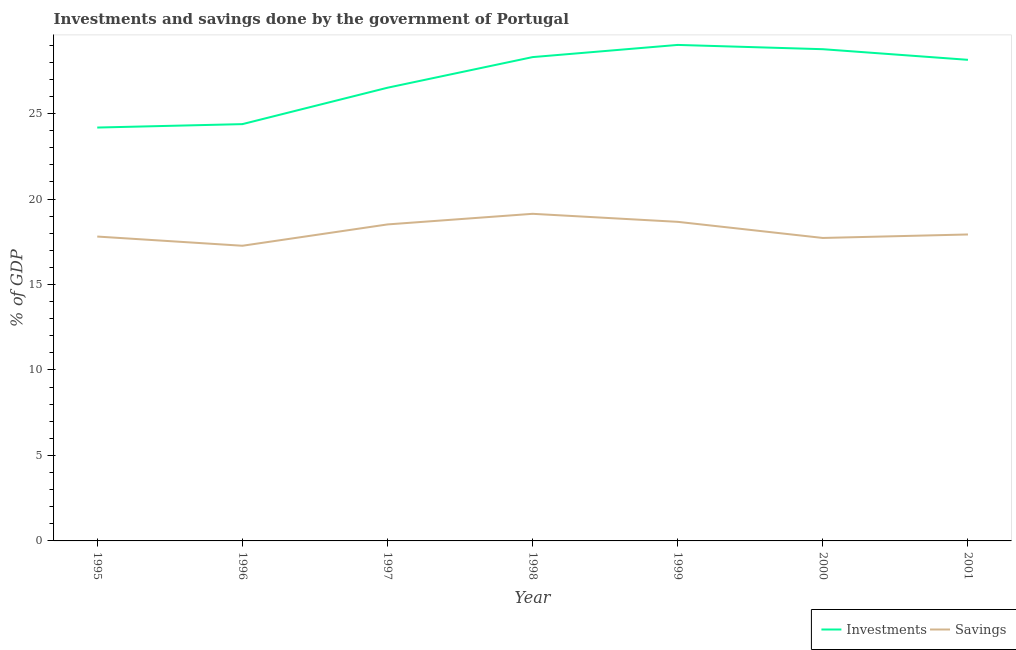Does the line corresponding to investments of government intersect with the line corresponding to savings of government?
Keep it short and to the point. No. What is the savings of government in 1998?
Ensure brevity in your answer.  19.13. Across all years, what is the maximum investments of government?
Ensure brevity in your answer.  29.01. Across all years, what is the minimum savings of government?
Keep it short and to the point. 17.27. In which year was the investments of government maximum?
Give a very brief answer. 1999. What is the total investments of government in the graph?
Your answer should be very brief. 189.3. What is the difference between the savings of government in 1997 and that in 2001?
Offer a terse response. 0.59. What is the difference between the investments of government in 1999 and the savings of government in 2000?
Keep it short and to the point. 11.29. What is the average investments of government per year?
Provide a succinct answer. 27.04. In the year 2000, what is the difference between the savings of government and investments of government?
Give a very brief answer. -11.04. What is the ratio of the savings of government in 1995 to that in 1999?
Offer a very short reply. 0.95. What is the difference between the highest and the second highest investments of government?
Offer a terse response. 0.25. What is the difference between the highest and the lowest savings of government?
Keep it short and to the point. 1.87. In how many years, is the savings of government greater than the average savings of government taken over all years?
Provide a succinct answer. 3. Is the savings of government strictly greater than the investments of government over the years?
Your response must be concise. No. How many lines are there?
Make the answer very short. 2. How many years are there in the graph?
Provide a succinct answer. 7. What is the difference between two consecutive major ticks on the Y-axis?
Your response must be concise. 5. Where does the legend appear in the graph?
Give a very brief answer. Bottom right. How many legend labels are there?
Your response must be concise. 2. What is the title of the graph?
Provide a succinct answer. Investments and savings done by the government of Portugal. What is the label or title of the Y-axis?
Make the answer very short. % of GDP. What is the % of GDP in Investments in 1995?
Offer a terse response. 24.18. What is the % of GDP in Savings in 1995?
Give a very brief answer. 17.8. What is the % of GDP of Investments in 1996?
Your answer should be compact. 24.38. What is the % of GDP in Savings in 1996?
Your answer should be very brief. 17.27. What is the % of GDP in Investments in 1997?
Your response must be concise. 26.51. What is the % of GDP in Savings in 1997?
Offer a very short reply. 18.51. What is the % of GDP of Investments in 1998?
Offer a terse response. 28.3. What is the % of GDP in Savings in 1998?
Your answer should be very brief. 19.13. What is the % of GDP of Investments in 1999?
Your response must be concise. 29.01. What is the % of GDP in Savings in 1999?
Ensure brevity in your answer.  18.67. What is the % of GDP in Investments in 2000?
Ensure brevity in your answer.  28.76. What is the % of GDP of Savings in 2000?
Offer a very short reply. 17.72. What is the % of GDP in Investments in 2001?
Offer a terse response. 28.14. What is the % of GDP of Savings in 2001?
Your response must be concise. 17.93. Across all years, what is the maximum % of GDP in Investments?
Ensure brevity in your answer.  29.01. Across all years, what is the maximum % of GDP of Savings?
Ensure brevity in your answer.  19.13. Across all years, what is the minimum % of GDP in Investments?
Make the answer very short. 24.18. Across all years, what is the minimum % of GDP of Savings?
Make the answer very short. 17.27. What is the total % of GDP in Investments in the graph?
Offer a terse response. 189.3. What is the total % of GDP in Savings in the graph?
Provide a succinct answer. 127.04. What is the difference between the % of GDP of Investments in 1995 and that in 1996?
Keep it short and to the point. -0.2. What is the difference between the % of GDP in Savings in 1995 and that in 1996?
Your answer should be compact. 0.54. What is the difference between the % of GDP of Investments in 1995 and that in 1997?
Give a very brief answer. -2.33. What is the difference between the % of GDP of Savings in 1995 and that in 1997?
Provide a short and direct response. -0.71. What is the difference between the % of GDP in Investments in 1995 and that in 1998?
Offer a terse response. -4.12. What is the difference between the % of GDP in Savings in 1995 and that in 1998?
Provide a succinct answer. -1.33. What is the difference between the % of GDP of Investments in 1995 and that in 1999?
Provide a succinct answer. -4.83. What is the difference between the % of GDP of Savings in 1995 and that in 1999?
Keep it short and to the point. -0.86. What is the difference between the % of GDP in Investments in 1995 and that in 2000?
Ensure brevity in your answer.  -4.58. What is the difference between the % of GDP of Savings in 1995 and that in 2000?
Make the answer very short. 0.08. What is the difference between the % of GDP of Investments in 1995 and that in 2001?
Provide a succinct answer. -3.96. What is the difference between the % of GDP in Savings in 1995 and that in 2001?
Give a very brief answer. -0.12. What is the difference between the % of GDP of Investments in 1996 and that in 1997?
Your response must be concise. -2.13. What is the difference between the % of GDP of Savings in 1996 and that in 1997?
Offer a very short reply. -1.25. What is the difference between the % of GDP of Investments in 1996 and that in 1998?
Ensure brevity in your answer.  -3.92. What is the difference between the % of GDP of Savings in 1996 and that in 1998?
Ensure brevity in your answer.  -1.87. What is the difference between the % of GDP of Investments in 1996 and that in 1999?
Your response must be concise. -4.63. What is the difference between the % of GDP in Savings in 1996 and that in 1999?
Your response must be concise. -1.4. What is the difference between the % of GDP of Investments in 1996 and that in 2000?
Offer a very short reply. -4.38. What is the difference between the % of GDP of Savings in 1996 and that in 2000?
Your answer should be very brief. -0.46. What is the difference between the % of GDP in Investments in 1996 and that in 2001?
Give a very brief answer. -3.76. What is the difference between the % of GDP of Savings in 1996 and that in 2001?
Your response must be concise. -0.66. What is the difference between the % of GDP of Investments in 1997 and that in 1998?
Your answer should be very brief. -1.79. What is the difference between the % of GDP of Savings in 1997 and that in 1998?
Make the answer very short. -0.62. What is the difference between the % of GDP of Investments in 1997 and that in 1999?
Your response must be concise. -2.5. What is the difference between the % of GDP in Savings in 1997 and that in 1999?
Your answer should be compact. -0.15. What is the difference between the % of GDP in Investments in 1997 and that in 2000?
Your response must be concise. -2.25. What is the difference between the % of GDP of Savings in 1997 and that in 2000?
Your answer should be compact. 0.79. What is the difference between the % of GDP in Investments in 1997 and that in 2001?
Make the answer very short. -1.63. What is the difference between the % of GDP in Savings in 1997 and that in 2001?
Offer a terse response. 0.59. What is the difference between the % of GDP of Investments in 1998 and that in 1999?
Keep it short and to the point. -0.71. What is the difference between the % of GDP in Savings in 1998 and that in 1999?
Provide a short and direct response. 0.47. What is the difference between the % of GDP in Investments in 1998 and that in 2000?
Your answer should be compact. -0.46. What is the difference between the % of GDP of Savings in 1998 and that in 2000?
Your answer should be compact. 1.41. What is the difference between the % of GDP of Investments in 1998 and that in 2001?
Give a very brief answer. 0.16. What is the difference between the % of GDP of Savings in 1998 and that in 2001?
Ensure brevity in your answer.  1.21. What is the difference between the % of GDP in Investments in 1999 and that in 2000?
Give a very brief answer. 0.25. What is the difference between the % of GDP of Savings in 1999 and that in 2000?
Ensure brevity in your answer.  0.94. What is the difference between the % of GDP in Investments in 1999 and that in 2001?
Make the answer very short. 0.87. What is the difference between the % of GDP of Savings in 1999 and that in 2001?
Your answer should be very brief. 0.74. What is the difference between the % of GDP of Investments in 2000 and that in 2001?
Your answer should be compact. 0.62. What is the difference between the % of GDP in Savings in 2000 and that in 2001?
Offer a terse response. -0.2. What is the difference between the % of GDP in Investments in 1995 and the % of GDP in Savings in 1996?
Provide a short and direct response. 6.91. What is the difference between the % of GDP in Investments in 1995 and the % of GDP in Savings in 1997?
Your answer should be very brief. 5.67. What is the difference between the % of GDP of Investments in 1995 and the % of GDP of Savings in 1998?
Keep it short and to the point. 5.05. What is the difference between the % of GDP in Investments in 1995 and the % of GDP in Savings in 1999?
Offer a very short reply. 5.52. What is the difference between the % of GDP in Investments in 1995 and the % of GDP in Savings in 2000?
Provide a short and direct response. 6.46. What is the difference between the % of GDP in Investments in 1995 and the % of GDP in Savings in 2001?
Your response must be concise. 6.25. What is the difference between the % of GDP of Investments in 1996 and the % of GDP of Savings in 1997?
Your response must be concise. 5.87. What is the difference between the % of GDP of Investments in 1996 and the % of GDP of Savings in 1998?
Offer a terse response. 5.25. What is the difference between the % of GDP of Investments in 1996 and the % of GDP of Savings in 1999?
Offer a very short reply. 5.72. What is the difference between the % of GDP of Investments in 1996 and the % of GDP of Savings in 2000?
Offer a terse response. 6.66. What is the difference between the % of GDP of Investments in 1996 and the % of GDP of Savings in 2001?
Your answer should be compact. 6.45. What is the difference between the % of GDP of Investments in 1997 and the % of GDP of Savings in 1998?
Make the answer very short. 7.38. What is the difference between the % of GDP in Investments in 1997 and the % of GDP in Savings in 1999?
Your response must be concise. 7.85. What is the difference between the % of GDP of Investments in 1997 and the % of GDP of Savings in 2000?
Provide a succinct answer. 8.79. What is the difference between the % of GDP in Investments in 1997 and the % of GDP in Savings in 2001?
Make the answer very short. 8.58. What is the difference between the % of GDP in Investments in 1998 and the % of GDP in Savings in 1999?
Keep it short and to the point. 9.64. What is the difference between the % of GDP in Investments in 1998 and the % of GDP in Savings in 2000?
Your answer should be compact. 10.58. What is the difference between the % of GDP of Investments in 1998 and the % of GDP of Savings in 2001?
Provide a short and direct response. 10.38. What is the difference between the % of GDP in Investments in 1999 and the % of GDP in Savings in 2000?
Your response must be concise. 11.29. What is the difference between the % of GDP of Investments in 1999 and the % of GDP of Savings in 2001?
Offer a terse response. 11.09. What is the difference between the % of GDP of Investments in 2000 and the % of GDP of Savings in 2001?
Keep it short and to the point. 10.84. What is the average % of GDP in Investments per year?
Offer a terse response. 27.04. What is the average % of GDP in Savings per year?
Offer a terse response. 18.15. In the year 1995, what is the difference between the % of GDP in Investments and % of GDP in Savings?
Provide a short and direct response. 6.38. In the year 1996, what is the difference between the % of GDP in Investments and % of GDP in Savings?
Keep it short and to the point. 7.11. In the year 1997, what is the difference between the % of GDP in Investments and % of GDP in Savings?
Your answer should be very brief. 8. In the year 1998, what is the difference between the % of GDP of Investments and % of GDP of Savings?
Your answer should be compact. 9.17. In the year 1999, what is the difference between the % of GDP of Investments and % of GDP of Savings?
Your response must be concise. 10.35. In the year 2000, what is the difference between the % of GDP of Investments and % of GDP of Savings?
Your answer should be compact. 11.04. In the year 2001, what is the difference between the % of GDP of Investments and % of GDP of Savings?
Your answer should be compact. 10.22. What is the ratio of the % of GDP in Savings in 1995 to that in 1996?
Give a very brief answer. 1.03. What is the ratio of the % of GDP of Investments in 1995 to that in 1997?
Provide a succinct answer. 0.91. What is the ratio of the % of GDP of Savings in 1995 to that in 1997?
Your answer should be compact. 0.96. What is the ratio of the % of GDP in Investments in 1995 to that in 1998?
Ensure brevity in your answer.  0.85. What is the ratio of the % of GDP in Savings in 1995 to that in 1998?
Offer a very short reply. 0.93. What is the ratio of the % of GDP of Investments in 1995 to that in 1999?
Offer a terse response. 0.83. What is the ratio of the % of GDP of Savings in 1995 to that in 1999?
Ensure brevity in your answer.  0.95. What is the ratio of the % of GDP of Investments in 1995 to that in 2000?
Make the answer very short. 0.84. What is the ratio of the % of GDP in Investments in 1995 to that in 2001?
Give a very brief answer. 0.86. What is the ratio of the % of GDP in Investments in 1996 to that in 1997?
Your response must be concise. 0.92. What is the ratio of the % of GDP in Savings in 1996 to that in 1997?
Your response must be concise. 0.93. What is the ratio of the % of GDP of Investments in 1996 to that in 1998?
Offer a terse response. 0.86. What is the ratio of the % of GDP of Savings in 1996 to that in 1998?
Give a very brief answer. 0.9. What is the ratio of the % of GDP of Investments in 1996 to that in 1999?
Make the answer very short. 0.84. What is the ratio of the % of GDP of Savings in 1996 to that in 1999?
Your response must be concise. 0.93. What is the ratio of the % of GDP in Investments in 1996 to that in 2000?
Provide a succinct answer. 0.85. What is the ratio of the % of GDP in Savings in 1996 to that in 2000?
Your answer should be compact. 0.97. What is the ratio of the % of GDP in Investments in 1996 to that in 2001?
Ensure brevity in your answer.  0.87. What is the ratio of the % of GDP of Savings in 1996 to that in 2001?
Keep it short and to the point. 0.96. What is the ratio of the % of GDP in Investments in 1997 to that in 1998?
Provide a short and direct response. 0.94. What is the ratio of the % of GDP in Savings in 1997 to that in 1998?
Provide a succinct answer. 0.97. What is the ratio of the % of GDP in Investments in 1997 to that in 1999?
Keep it short and to the point. 0.91. What is the ratio of the % of GDP in Savings in 1997 to that in 1999?
Ensure brevity in your answer.  0.99. What is the ratio of the % of GDP in Investments in 1997 to that in 2000?
Give a very brief answer. 0.92. What is the ratio of the % of GDP in Savings in 1997 to that in 2000?
Your answer should be compact. 1.04. What is the ratio of the % of GDP of Investments in 1997 to that in 2001?
Your response must be concise. 0.94. What is the ratio of the % of GDP in Savings in 1997 to that in 2001?
Offer a very short reply. 1.03. What is the ratio of the % of GDP of Investments in 1998 to that in 1999?
Give a very brief answer. 0.98. What is the ratio of the % of GDP in Savings in 1998 to that in 1999?
Your answer should be compact. 1.03. What is the ratio of the % of GDP of Investments in 1998 to that in 2000?
Offer a very short reply. 0.98. What is the ratio of the % of GDP in Savings in 1998 to that in 2000?
Offer a very short reply. 1.08. What is the ratio of the % of GDP of Investments in 1998 to that in 2001?
Make the answer very short. 1.01. What is the ratio of the % of GDP of Savings in 1998 to that in 2001?
Your answer should be very brief. 1.07. What is the ratio of the % of GDP in Investments in 1999 to that in 2000?
Offer a very short reply. 1.01. What is the ratio of the % of GDP of Savings in 1999 to that in 2000?
Your response must be concise. 1.05. What is the ratio of the % of GDP in Investments in 1999 to that in 2001?
Keep it short and to the point. 1.03. What is the ratio of the % of GDP in Savings in 1999 to that in 2001?
Give a very brief answer. 1.04. What is the ratio of the % of GDP in Investments in 2000 to that in 2001?
Your answer should be very brief. 1.02. What is the difference between the highest and the second highest % of GDP in Investments?
Keep it short and to the point. 0.25. What is the difference between the highest and the second highest % of GDP in Savings?
Give a very brief answer. 0.47. What is the difference between the highest and the lowest % of GDP in Investments?
Provide a short and direct response. 4.83. What is the difference between the highest and the lowest % of GDP of Savings?
Provide a short and direct response. 1.87. 